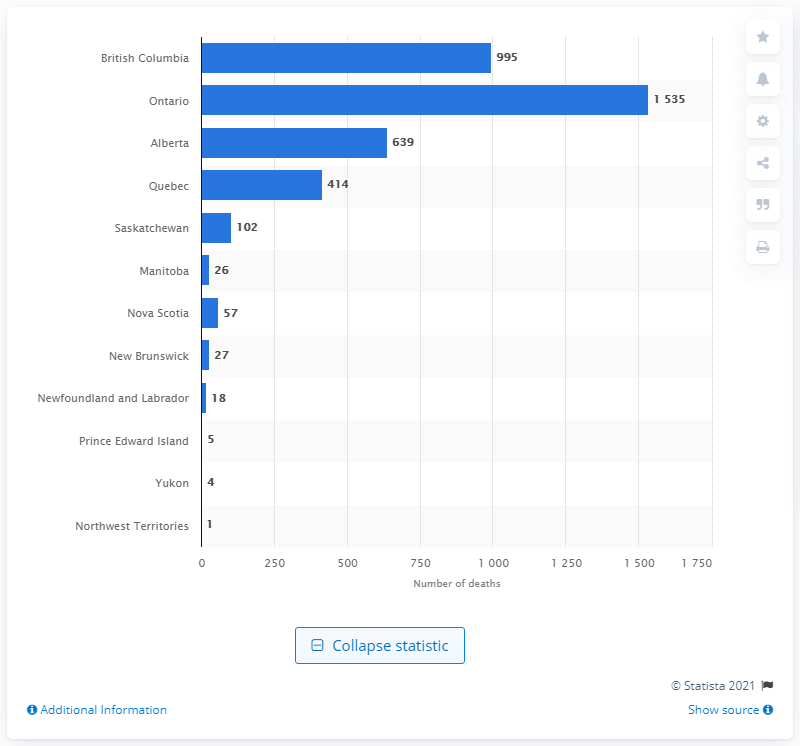Specify some key components in this picture. In British Columbia in 2019, there were 995 reported deaths. 